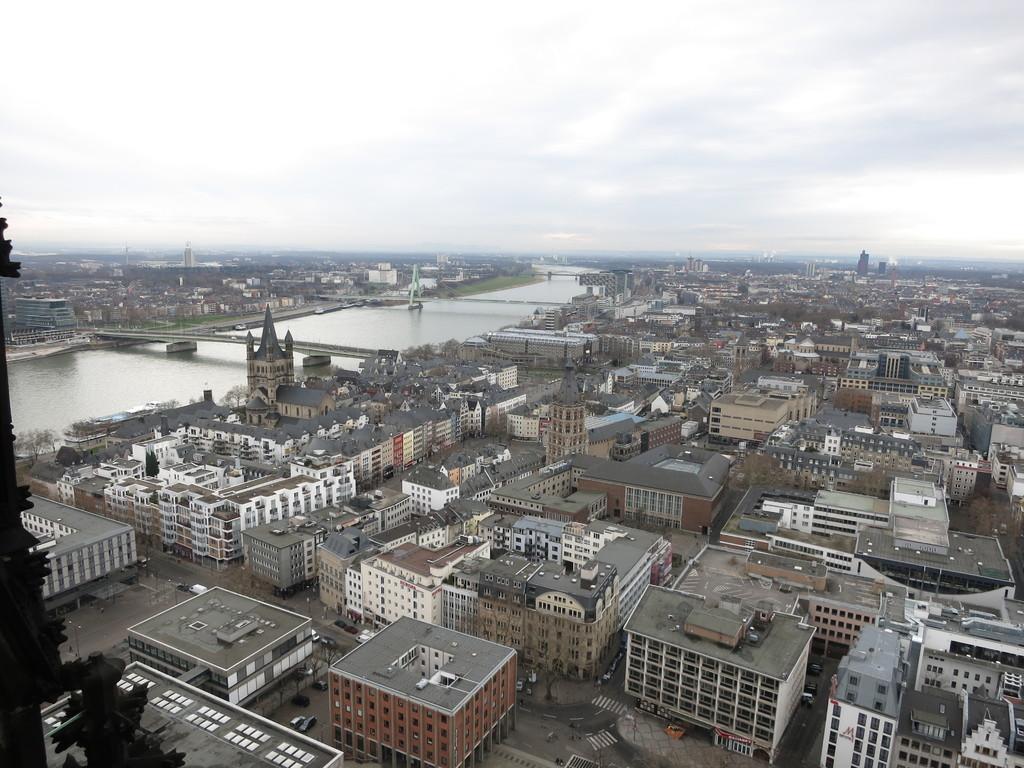How would you summarize this image in a sentence or two? This picture consists of an urban area, which consists of buildings, cars, and bridges in the image. 